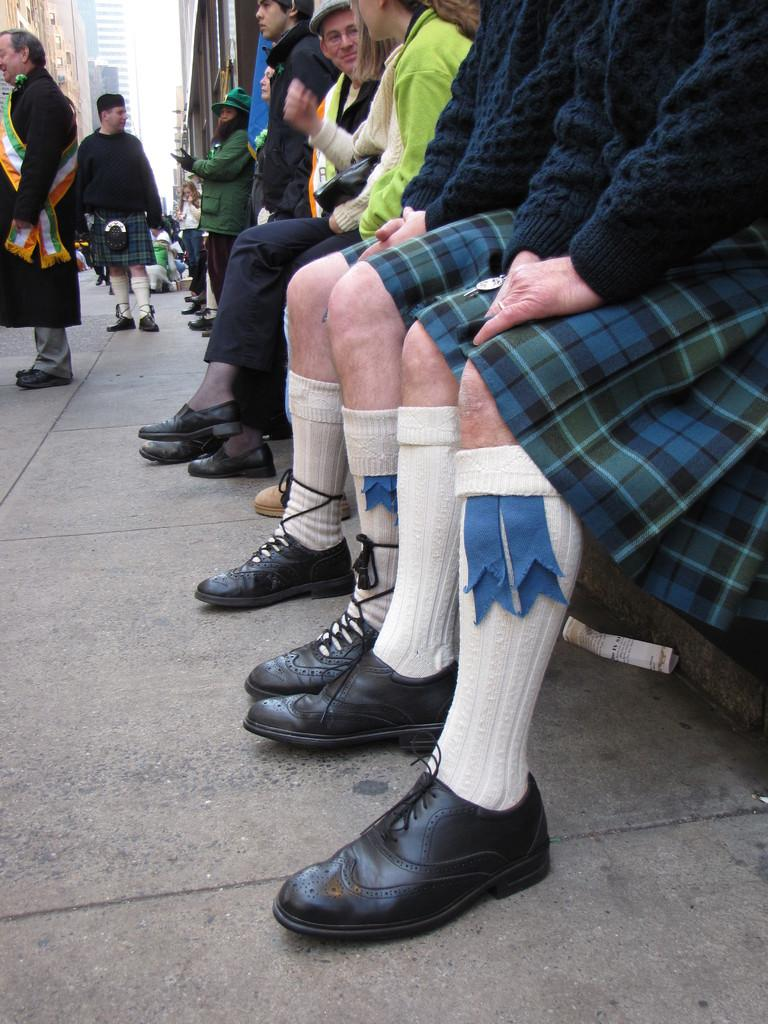What are the people in the image doing? The people in the image are sitting and standing in the middle of the image. What can be seen in the background of the image? There are buildings visible at the top of the image. What type of glue is being used to hold the rose in the image? There is no rose or glue present in the image. 